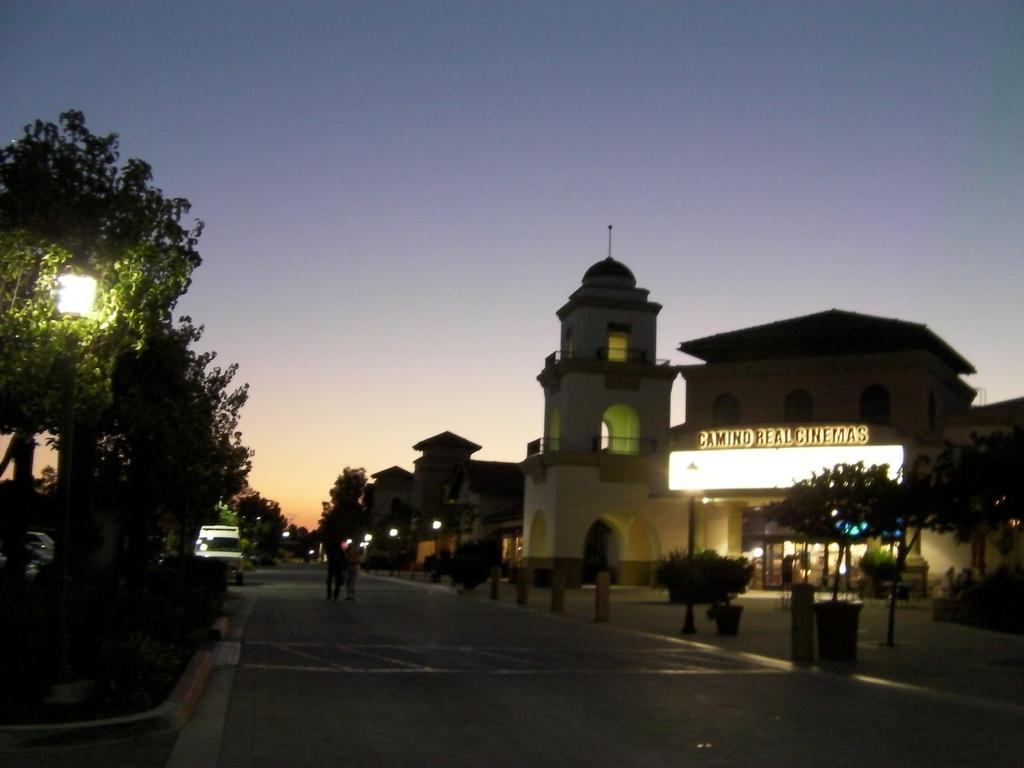What is the main feature of the image? There is a road in the image. What are the people in the image doing? People are walking on the road. What can be seen on either side of the road? There are trees and light poles on either side of the road. What is visible in the background of the image? There is a building and the sky in the background of the image. What type of yarn is being used to decorate the trees in the image? There is no yarn present in the image, and the trees are not being decorated. Can you tell me how many dolls are sitting on the light poles in the image? There are no dolls present in the image, and they are not sitting on the light poles. 